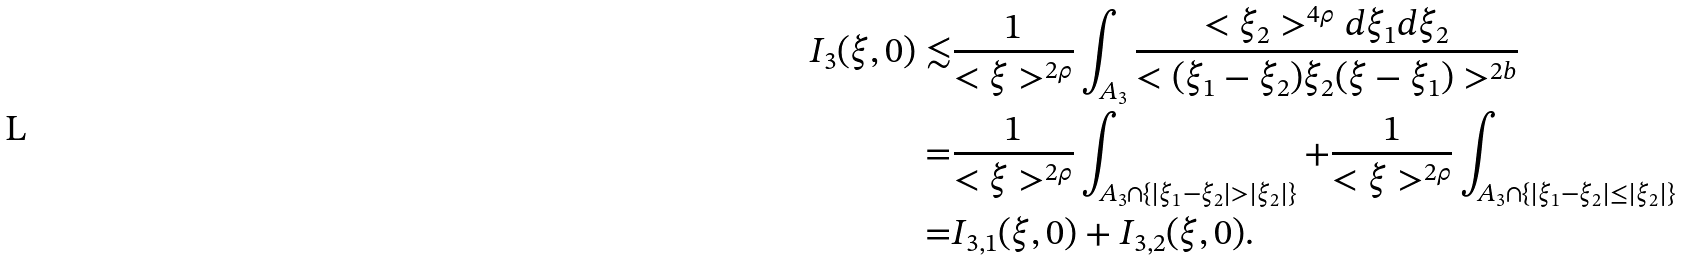<formula> <loc_0><loc_0><loc_500><loc_500>I _ { 3 } ( \xi , 0 ) \lesssim & \frac { 1 } { < \xi > ^ { 2 \rho } } \int _ { A _ { 3 } } \frac { < \xi _ { 2 } > ^ { 4 \rho } d \xi _ { 1 } d \xi _ { 2 } } { < ( \xi _ { 1 } - \xi _ { 2 } ) \xi _ { 2 } ( \xi - \xi _ { 1 } ) > ^ { 2 b } } \\ = & \frac { 1 } { < \xi > ^ { 2 \rho } } \int _ { A _ { 3 } \cap \{ | \xi _ { 1 } - \xi _ { 2 } | > | \xi _ { 2 } | \} } + \frac { 1 } { < \xi > ^ { 2 \rho } } \int _ { A _ { 3 } \cap \{ | \xi _ { 1 } - \xi _ { 2 } | \leq | \xi _ { 2 } | \} } \\ = & I _ { 3 , 1 } ( \xi , 0 ) + I _ { 3 , 2 } ( \xi , 0 ) .</formula> 